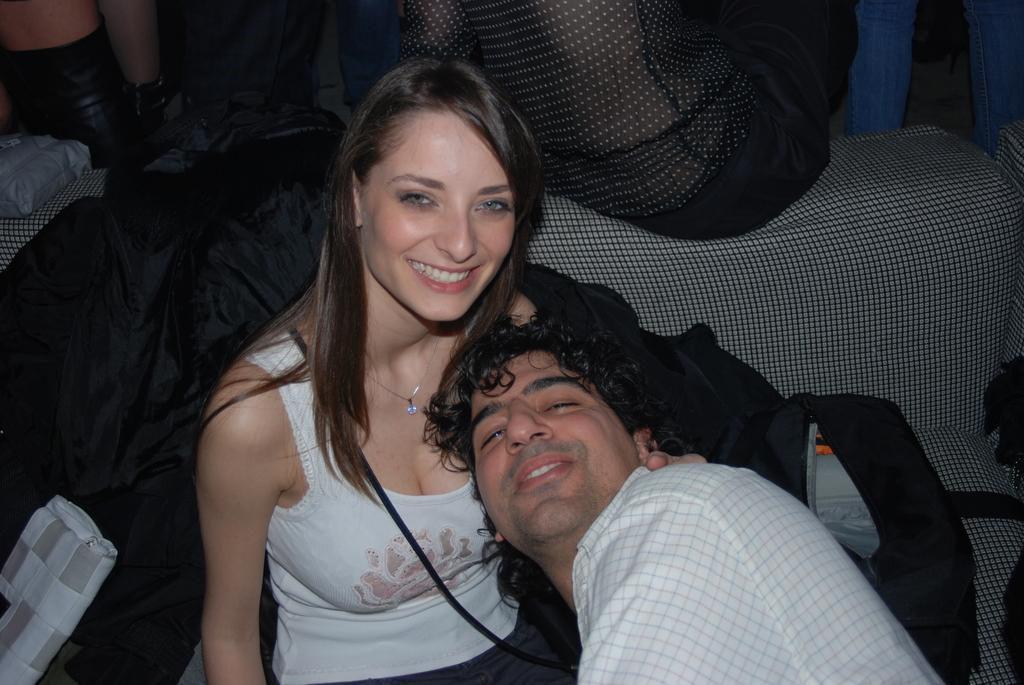What is the woman doing in the image? The woman is sitting on a couch in the image. Who is sitting beside the woman on the couch? There is a man sitting beside the woman on the couch. What can be seen in the background of the image? There are bags in the background of the image. How is the background of the image depicted? The background is blurred. What type of polish is the woman applying to her nails in the image? There is no indication in the image that the woman is applying polish to her nails, and therefore no such activity can be observed. 